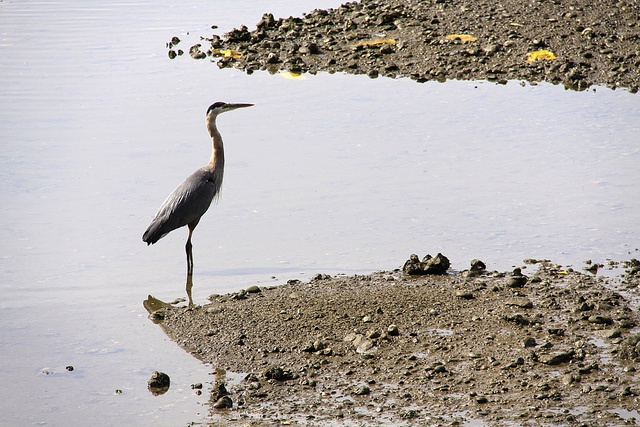Describe the objects in this image and their specific colors. I can see a bird in lavender, black, gray, darkgray, and lightgray tones in this image. 